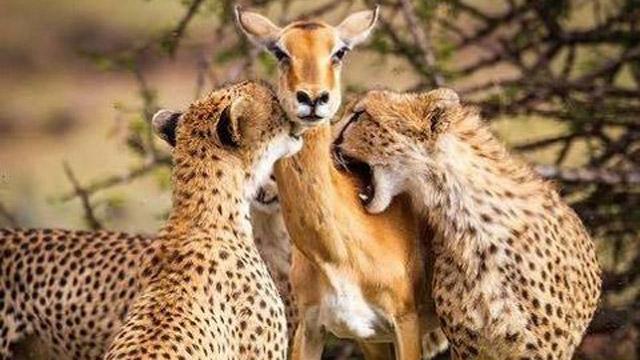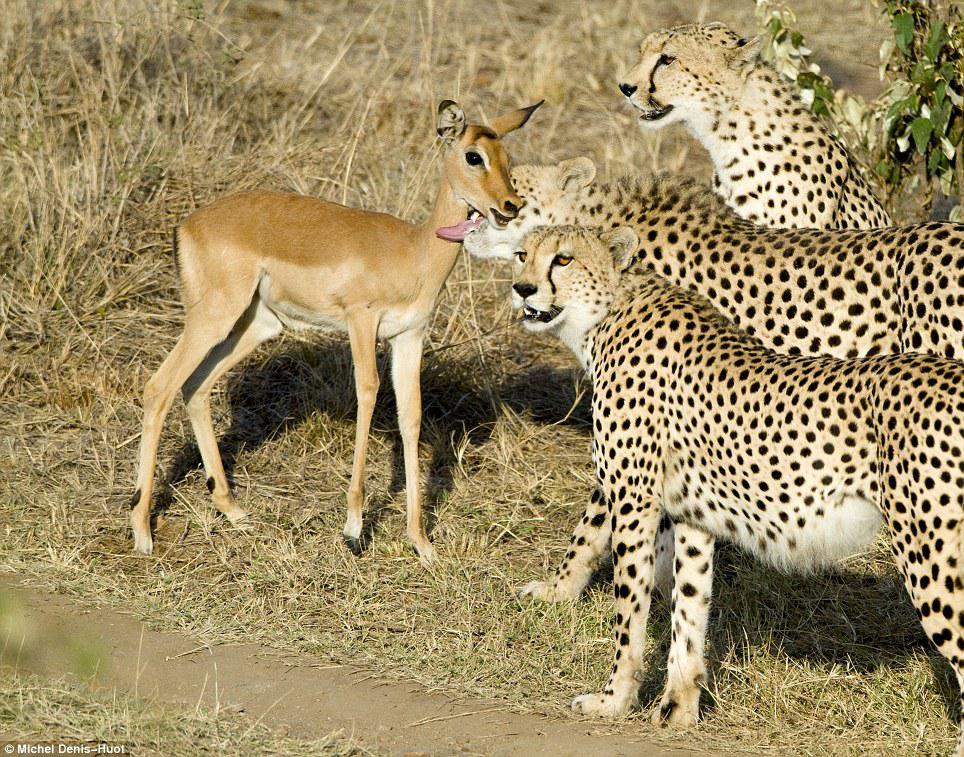The first image is the image on the left, the second image is the image on the right. Considering the images on both sides, is "In one image there is a pair of cheetahs biting an antelope on the neck." valid? Answer yes or no. Yes. 